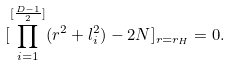Convert formula to latex. <formula><loc_0><loc_0><loc_500><loc_500>[ \prod _ { i = 1 } ^ { [ { \frac { D - 1 } { 2 } } ] } ( r ^ { 2 } + l _ { i } ^ { 2 } ) - 2 N ] _ { r = r _ { H } } = 0 .</formula> 